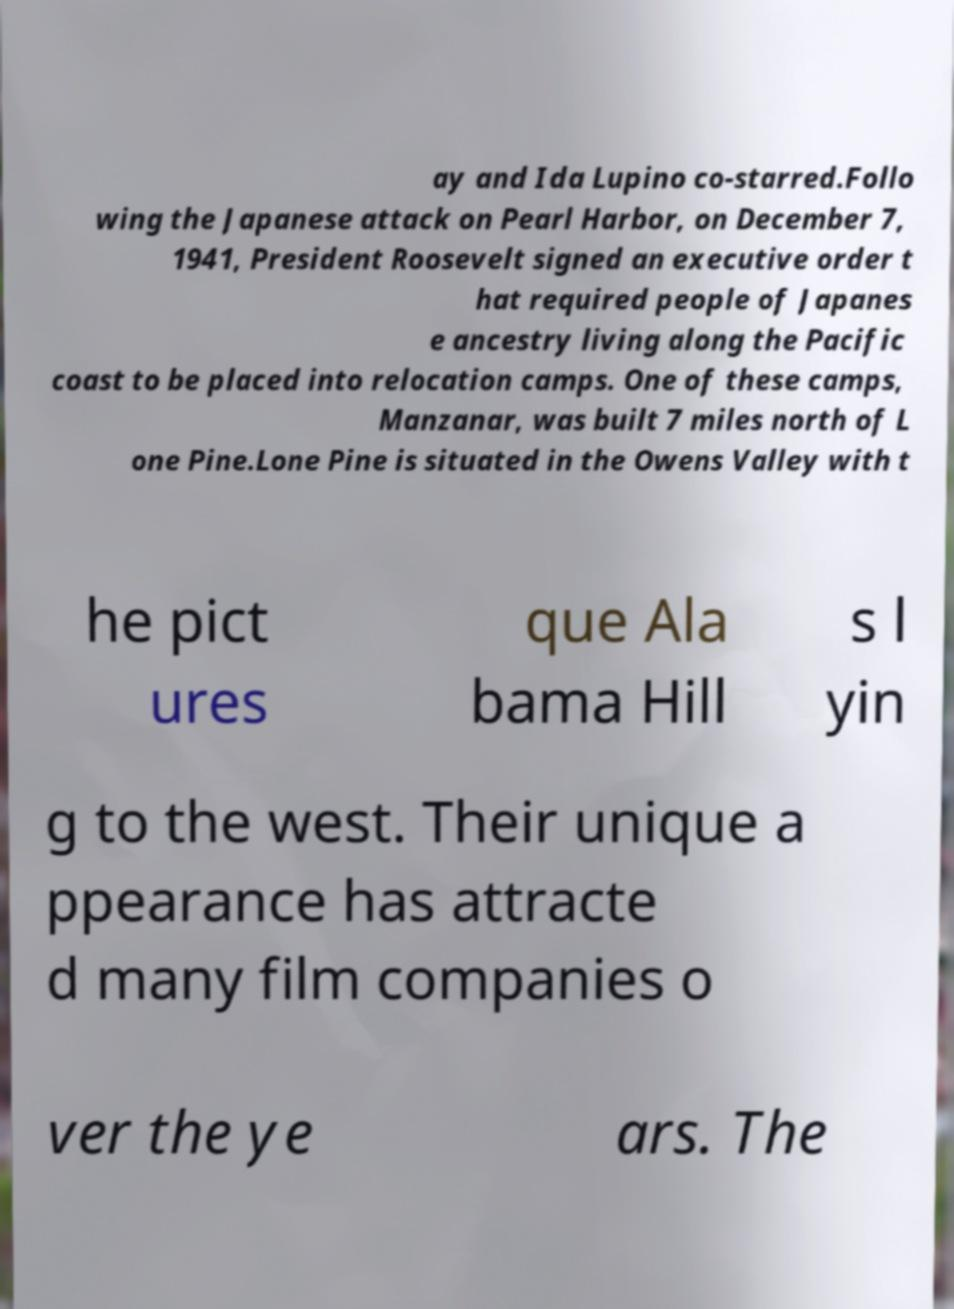Could you extract and type out the text from this image? ay and Ida Lupino co-starred.Follo wing the Japanese attack on Pearl Harbor, on December 7, 1941, President Roosevelt signed an executive order t hat required people of Japanes e ancestry living along the Pacific coast to be placed into relocation camps. One of these camps, Manzanar, was built 7 miles north of L one Pine.Lone Pine is situated in the Owens Valley with t he pict ures que Ala bama Hill s l yin g to the west. Their unique a ppearance has attracte d many film companies o ver the ye ars. The 